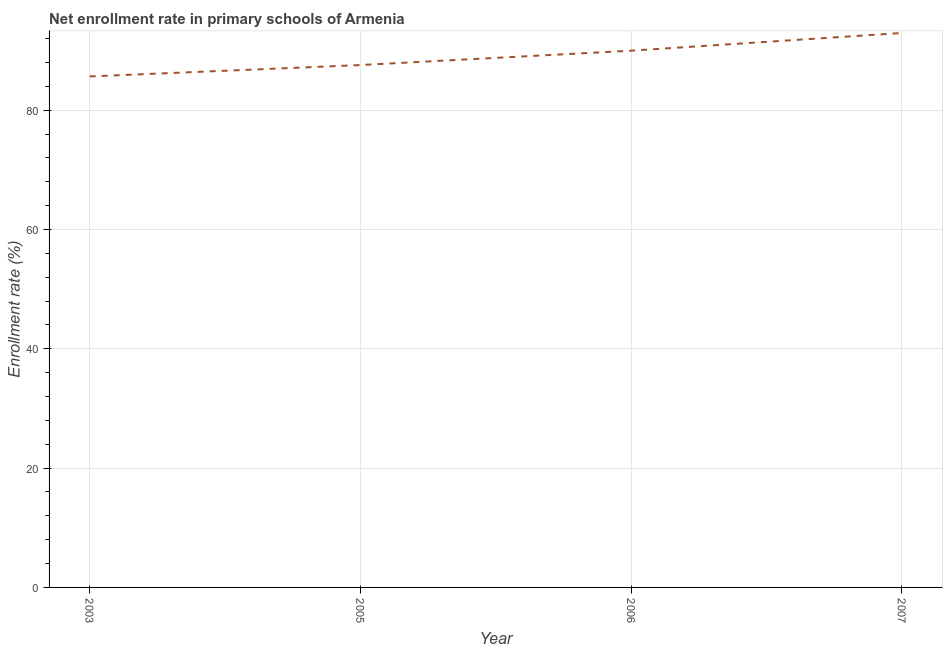What is the net enrollment rate in primary schools in 2005?
Make the answer very short. 87.56. Across all years, what is the maximum net enrollment rate in primary schools?
Offer a very short reply. 92.93. Across all years, what is the minimum net enrollment rate in primary schools?
Your answer should be very brief. 85.65. In which year was the net enrollment rate in primary schools maximum?
Your response must be concise. 2007. What is the sum of the net enrollment rate in primary schools?
Provide a succinct answer. 356.11. What is the difference between the net enrollment rate in primary schools in 2003 and 2005?
Your answer should be very brief. -1.91. What is the average net enrollment rate in primary schools per year?
Your answer should be very brief. 89.03. What is the median net enrollment rate in primary schools?
Give a very brief answer. 88.76. What is the ratio of the net enrollment rate in primary schools in 2003 to that in 2006?
Your response must be concise. 0.95. Is the net enrollment rate in primary schools in 2003 less than that in 2005?
Give a very brief answer. Yes. Is the difference between the net enrollment rate in primary schools in 2006 and 2007 greater than the difference between any two years?
Keep it short and to the point. No. What is the difference between the highest and the second highest net enrollment rate in primary schools?
Provide a short and direct response. 2.96. What is the difference between the highest and the lowest net enrollment rate in primary schools?
Give a very brief answer. 7.28. How many lines are there?
Your answer should be compact. 1. How many years are there in the graph?
Ensure brevity in your answer.  4. Are the values on the major ticks of Y-axis written in scientific E-notation?
Give a very brief answer. No. What is the title of the graph?
Keep it short and to the point. Net enrollment rate in primary schools of Armenia. What is the label or title of the Y-axis?
Offer a very short reply. Enrollment rate (%). What is the Enrollment rate (%) in 2003?
Offer a very short reply. 85.65. What is the Enrollment rate (%) in 2005?
Offer a terse response. 87.56. What is the Enrollment rate (%) of 2006?
Provide a succinct answer. 89.97. What is the Enrollment rate (%) of 2007?
Your response must be concise. 92.93. What is the difference between the Enrollment rate (%) in 2003 and 2005?
Your answer should be very brief. -1.91. What is the difference between the Enrollment rate (%) in 2003 and 2006?
Make the answer very short. -4.32. What is the difference between the Enrollment rate (%) in 2003 and 2007?
Keep it short and to the point. -7.28. What is the difference between the Enrollment rate (%) in 2005 and 2006?
Offer a terse response. -2.41. What is the difference between the Enrollment rate (%) in 2005 and 2007?
Your answer should be compact. -5.37. What is the difference between the Enrollment rate (%) in 2006 and 2007?
Provide a short and direct response. -2.96. What is the ratio of the Enrollment rate (%) in 2003 to that in 2005?
Keep it short and to the point. 0.98. What is the ratio of the Enrollment rate (%) in 2003 to that in 2006?
Give a very brief answer. 0.95. What is the ratio of the Enrollment rate (%) in 2003 to that in 2007?
Your answer should be compact. 0.92. What is the ratio of the Enrollment rate (%) in 2005 to that in 2007?
Provide a succinct answer. 0.94. 